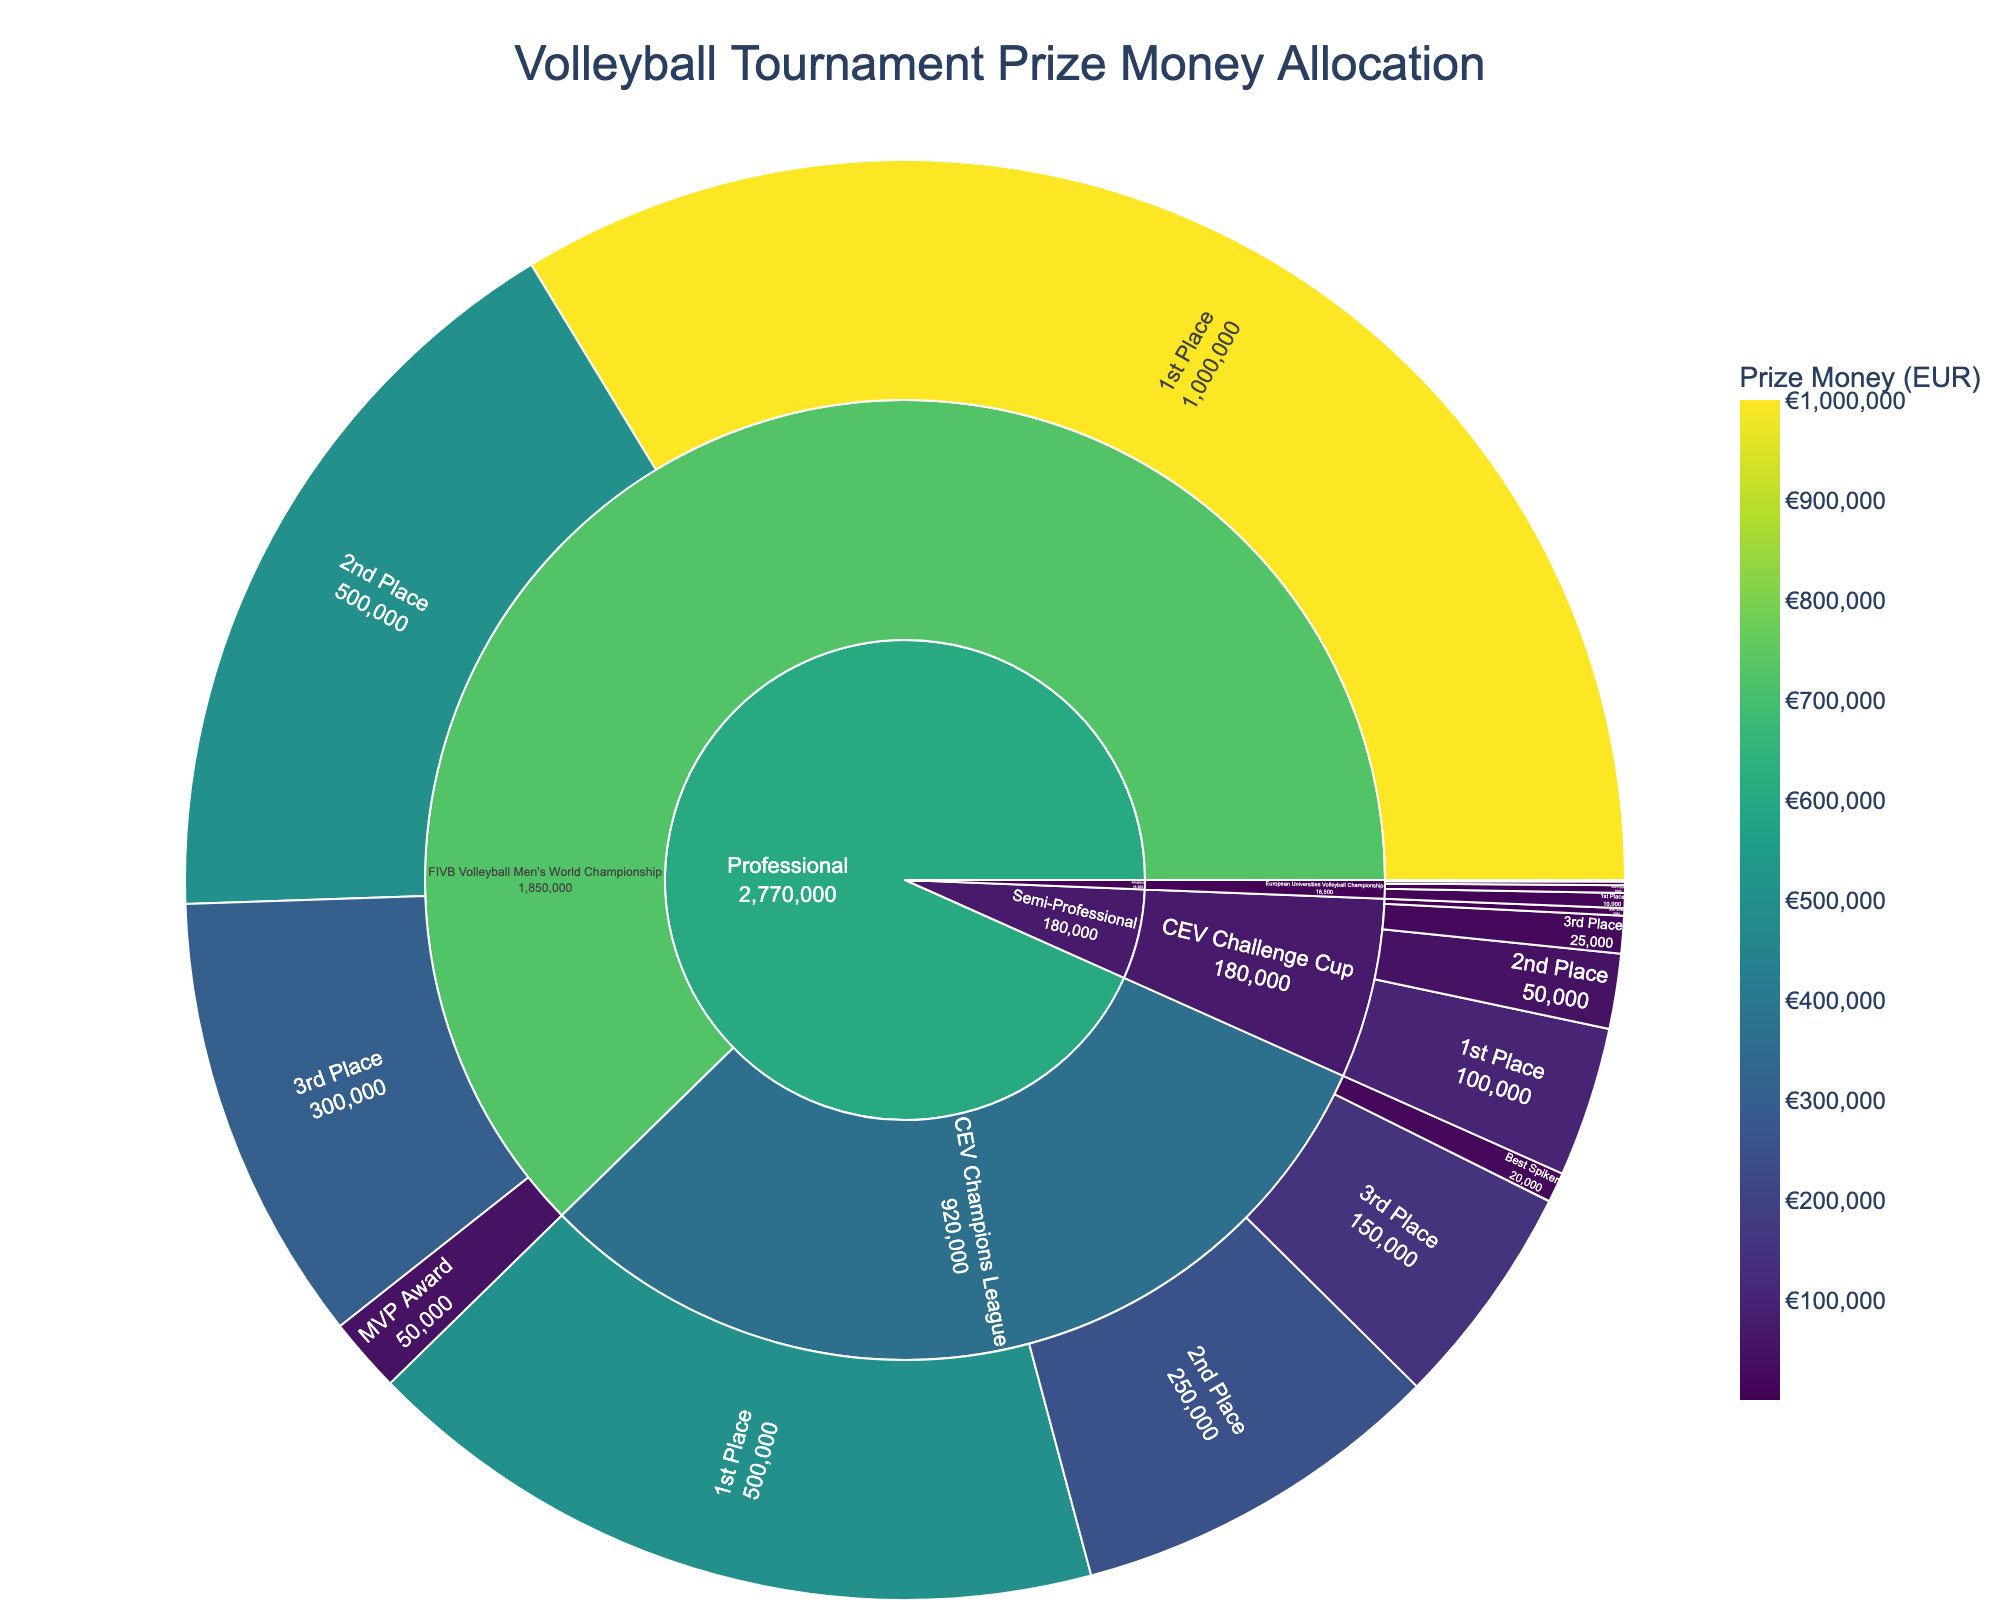What is the sum of prize money for the first and second places in the CEV Champions League? Add the prize money for "1st Place" and "2nd Place" under the "CEV Champions League". €500,000 + €250,000 = €750,000
Answer: €750,000 Which placement level has the least prize money in the European Universities Volleyball Championship? Look under the "Amateur" section at the "European Universities Volleyball Championship" placements. The "Best Libero" award has the least prize money.
Answer: Best Libero Compare the total prize money awarded in the Professional and Amateur competition levels. Sum the prize money across all placements for Professional and Amateur categories. For Professional: €2,770,000; for Amateur: €18,500.
Answer: Professional: €2,770,000; Amateur: €18,500 Which individual award has the highest prize money? Look at the placements under both Professional and Semi-Professional sections to find "individual awards" (Best Spiker, MVP Award, Best Setter, Best Libero). The "MVP Award" in the "FIVB Volleyball Men's World Championship" has the highest prize money.
Answer: MVP Award What is the average prize money for the 3rd place across all competitions? Sum the prize money for the "3rd Place" in all competitions and divide by the number of "3rd Place" entries. (€300,000 + €150,000 + €25,000 + €2,500)/4 = €118,125
Answer: €118,125 How does the prize money for Best Setter in the CEV Challenge Cup compare to the prize for the Best Spiker in the CEV Champions League? Compare the values of "Best Setter" in the "CEV Challenge Cup" (€5,000) and "Best Spiker" in the "CEV Champions League" (€20,000). The Best Spiker award is higher.
Answer: Best Spiker is higher What is the difference in prize money for 2nd place between the FIVB Volleyball Men's World Championship and the CEV Challenge Cup? Subtract the prize money for the "2nd Place" in the "CEV Challenge Cup" (€50,000) from the "2nd Place" in the "FIVB Volleyball Men's World Championship" (€500,000). €500,000 - €50,000 = €450,000
Answer: €450,000 